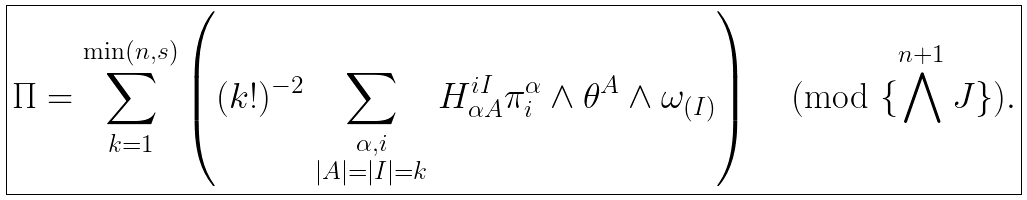Convert formula to latex. <formula><loc_0><loc_0><loc_500><loc_500>\boxed { \Pi = \sum _ { k = 1 } ^ { \min ( n , s ) } \left ( ( k ! ) ^ { - 2 } \sum _ { \begin{smallmatrix} \alpha , i \\ | A | = | I | = k \end{smallmatrix} } H ^ { i I } _ { \alpha A } \pi ^ { \alpha } _ { i } \wedge \theta ^ { A } \wedge \omega _ { ( I ) } \right ) \pmod { \{ \bigwedge ^ { n + 1 } J \} } . }</formula> 